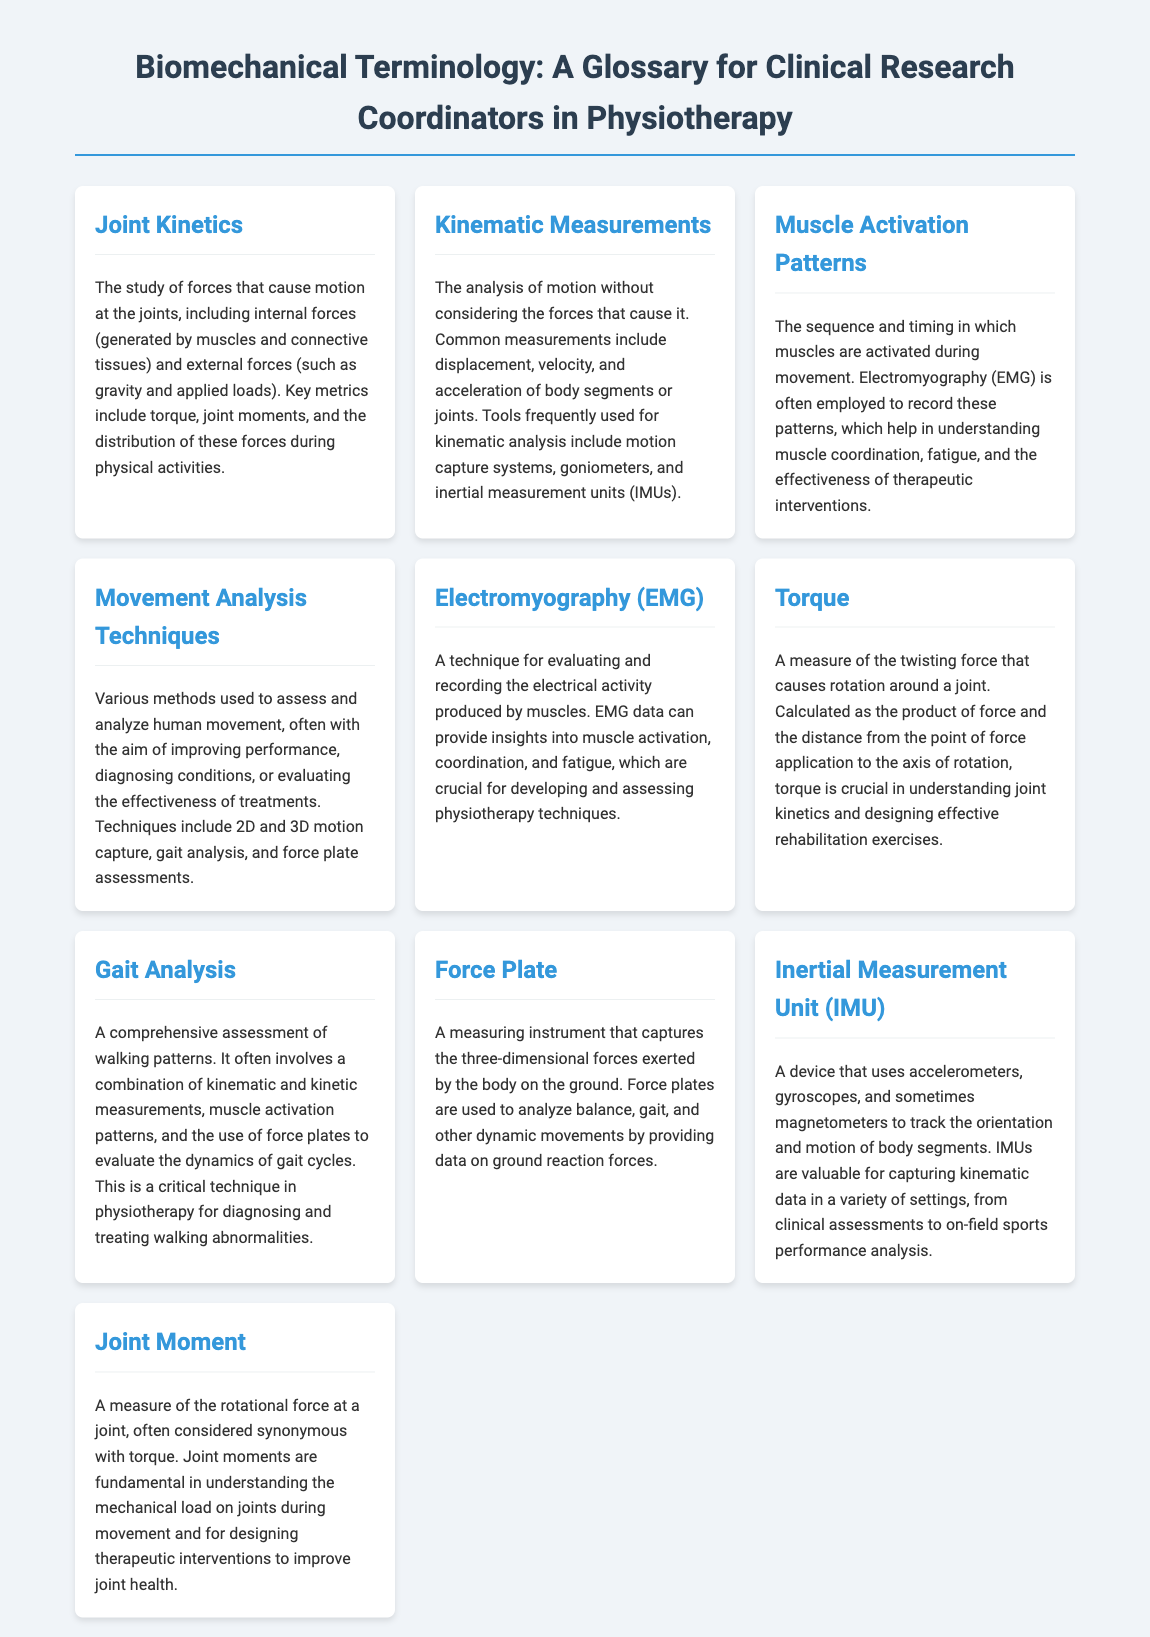what is the primary focus of joint kinetics? Joint kinetics focuses on the study of forces causing motion at the joints, including internal and external forces.
Answer: forces causing motion at the joints what technique is commonly used to record muscle activation patterns? Electromyography (EMG) is employed to record muscle activation patterns during movement.
Answer: Electromyography (EMG) what are common measurements in kinematic analysis? Common measurements include displacement, velocity, and acceleration of body segments or joints.
Answer: displacement, velocity, acceleration what is the purpose of gait analysis in physiotherapy? Gait analysis aims to evaluate walking patterns and the dynamics of gait cycles, critical for diagnosing and treating walking abnormalities.
Answer: evaluate walking patterns what device is used to capture ground reaction forces? A force plate is used to analyze balance, gait, and other dynamic movements by capturing ground reaction forces.
Answer: force plate how is torque calculated? Torque is calculated as the product of force and the distance from the point of force application to the axis of rotation.
Answer: product of force and distance what device combines accelerometers and gyroscopes for motion tracking? An Inertial Measurement Unit (IMU) uses accelerometers and gyroscopes to track motion and orientation of body segments.
Answer: Inertial Measurement Unit (IMU) which analysis method includes both kinematic and kinetic measurements? Gait analysis includes a combination of kinematic and kinetic measurements to assess walking patterns.
Answer: Gait analysis how are joint moments related to torque? Joint moments are often considered synonymous with torque in the context of joint mechanics and movement.
Answer: synonymous with torque 